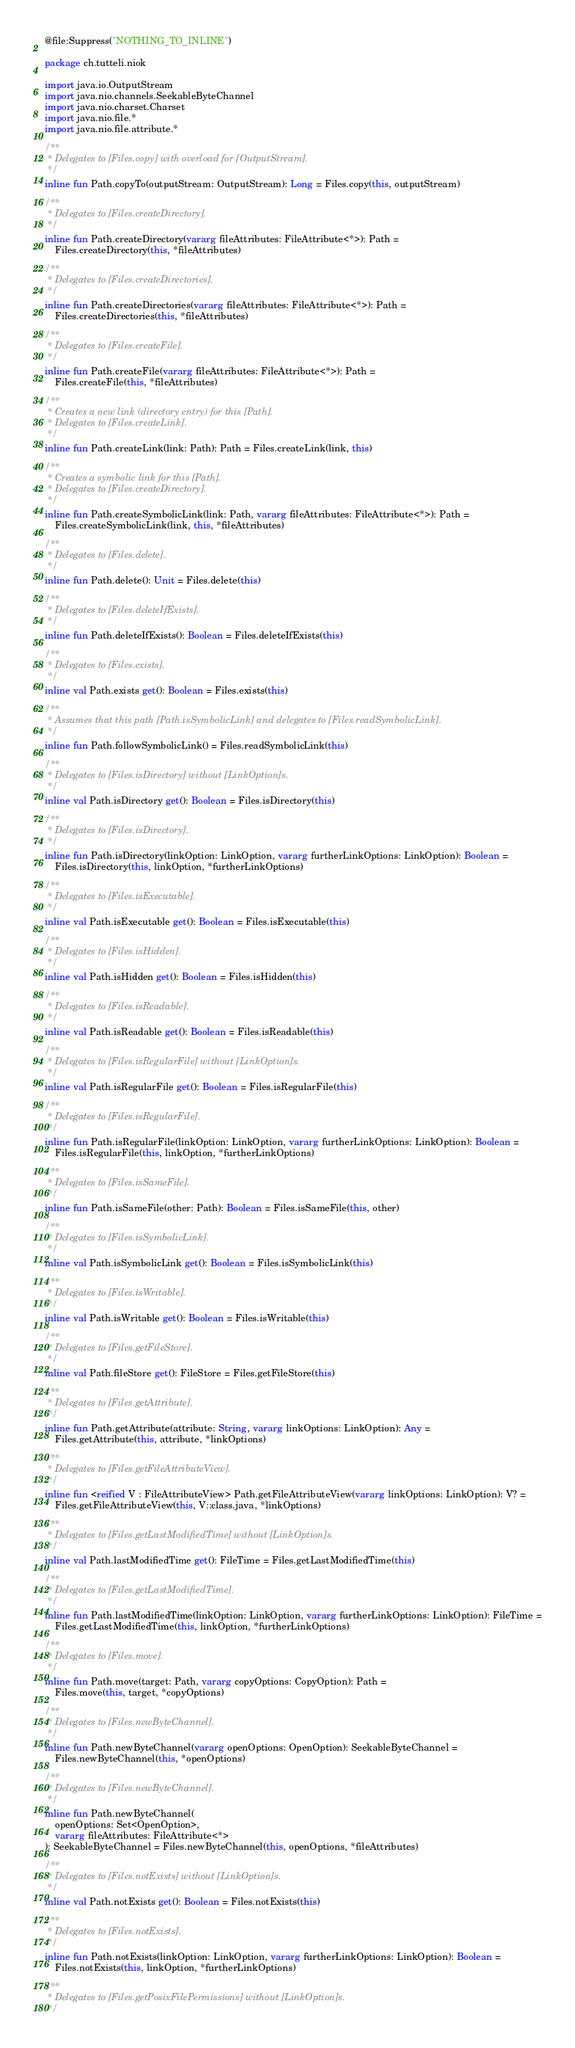Convert code to text. <code><loc_0><loc_0><loc_500><loc_500><_Kotlin_>@file:Suppress("NOTHING_TO_INLINE")

package ch.tutteli.niok

import java.io.OutputStream
import java.nio.channels.SeekableByteChannel
import java.nio.charset.Charset
import java.nio.file.*
import java.nio.file.attribute.*

/**
 * Delegates to [Files.copy] with overload for [OutputStream].
 */
inline fun Path.copyTo(outputStream: OutputStream): Long = Files.copy(this, outputStream)

/**
 * Delegates to [Files.createDirectory].
 */
inline fun Path.createDirectory(vararg fileAttributes: FileAttribute<*>): Path =
    Files.createDirectory(this, *fileAttributes)

/**
 * Delegates to [Files.createDirectories].
 */
inline fun Path.createDirectories(vararg fileAttributes: FileAttribute<*>): Path =
    Files.createDirectories(this, *fileAttributes)

/**
 * Delegates to [Files.createFile].
 */
inline fun Path.createFile(vararg fileAttributes: FileAttribute<*>): Path =
    Files.createFile(this, *fileAttributes)

/**
 * Creates a new link (directory entry) for this [Path].
 * Delegates to [Files.createLink].
 */
inline fun Path.createLink(link: Path): Path = Files.createLink(link, this)

/**
 * Creates a symbolic link for this [Path].
 * Delegates to [Files.createDirectory].
 */
inline fun Path.createSymbolicLink(link: Path, vararg fileAttributes: FileAttribute<*>): Path =
    Files.createSymbolicLink(link, this, *fileAttributes)

/**
 * Delegates to [Files.delete].
 */
inline fun Path.delete(): Unit = Files.delete(this)

/**
 * Delegates to [Files.deleteIfExists].
 */
inline fun Path.deleteIfExists(): Boolean = Files.deleteIfExists(this)

/**
 * Delegates to [Files.exists].
 */
inline val Path.exists get(): Boolean = Files.exists(this)

/**
 * Assumes that this path [Path.isSymbolicLink] and delegates to [Files.readSymbolicLink].
 */
inline fun Path.followSymbolicLink() = Files.readSymbolicLink(this)

/**
 * Delegates to [Files.isDirectory] without [LinkOption]s.
 */
inline val Path.isDirectory get(): Boolean = Files.isDirectory(this)

/**
 * Delegates to [Files.isDirectory].
 */
inline fun Path.isDirectory(linkOption: LinkOption, vararg furtherLinkOptions: LinkOption): Boolean =
    Files.isDirectory(this, linkOption, *furtherLinkOptions)

/**
 * Delegates to [Files.isExecutable].
 */
inline val Path.isExecutable get(): Boolean = Files.isExecutable(this)

/**
 * Delegates to [Files.isHidden].
 */
inline val Path.isHidden get(): Boolean = Files.isHidden(this)

/**
 * Delegates to [Files.isReadable].
 */
inline val Path.isReadable get(): Boolean = Files.isReadable(this)

/**
 * Delegates to [Files.isRegularFile] without [LinkOption]s.
 */
inline val Path.isRegularFile get(): Boolean = Files.isRegularFile(this)

/**
 * Delegates to [Files.isRegularFile].
 */
inline fun Path.isRegularFile(linkOption: LinkOption, vararg furtherLinkOptions: LinkOption): Boolean =
    Files.isRegularFile(this, linkOption, *furtherLinkOptions)

/**
 * Delegates to [Files.isSameFile].
 */
inline fun Path.isSameFile(other: Path): Boolean = Files.isSameFile(this, other)

/**
 * Delegates to [Files.isSymbolicLink].
 */
inline val Path.isSymbolicLink get(): Boolean = Files.isSymbolicLink(this)

/**
 * Delegates to [Files.isWritable].
 */
inline val Path.isWritable get(): Boolean = Files.isWritable(this)

/**
 * Delegates to [Files.getFileStore].
 */
inline val Path.fileStore get(): FileStore = Files.getFileStore(this)

/**
 * Delegates to [Files.getAttribute].
 */
inline fun Path.getAttribute(attribute: String, vararg linkOptions: LinkOption): Any =
    Files.getAttribute(this, attribute, *linkOptions)

/**
 * Delegates to [Files.getFileAttributeView].
 */
inline fun <reified V : FileAttributeView> Path.getFileAttributeView(vararg linkOptions: LinkOption): V? =
    Files.getFileAttributeView(this, V::class.java, *linkOptions)

/**
 * Delegates to [Files.getLastModifiedTime] without [LinkOption]s.
 */
inline val Path.lastModifiedTime get(): FileTime = Files.getLastModifiedTime(this)

/**
 * Delegates to [Files.getLastModifiedTime].
 */
inline fun Path.lastModifiedTime(linkOption: LinkOption, vararg furtherLinkOptions: LinkOption): FileTime =
    Files.getLastModifiedTime(this, linkOption, *furtherLinkOptions)

/**
 * Delegates to [Files.move].
 */
inline fun Path.move(target: Path, vararg copyOptions: CopyOption): Path =
    Files.move(this, target, *copyOptions)

/**
 * Delegates to [Files.newByteChannel].
 */
inline fun Path.newByteChannel(vararg openOptions: OpenOption): SeekableByteChannel =
    Files.newByteChannel(this, *openOptions)

/**
 * Delegates to [Files.newByteChannel].
 */
inline fun Path.newByteChannel(
    openOptions: Set<OpenOption>,
    vararg fileAttributes: FileAttribute<*>
): SeekableByteChannel = Files.newByteChannel(this, openOptions, *fileAttributes)

/**
 * Delegates to [Files.notExists] without [LinkOption]s.
 */
inline val Path.notExists get(): Boolean = Files.notExists(this)

/**
 * Delegates to [Files.notExists].
 */
inline fun Path.notExists(linkOption: LinkOption, vararg furtherLinkOptions: LinkOption): Boolean =
    Files.notExists(this, linkOption, *furtherLinkOptions)

/**
 * Delegates to [Files.getPosixFilePermissions] without [LinkOption]s.
 */</code> 